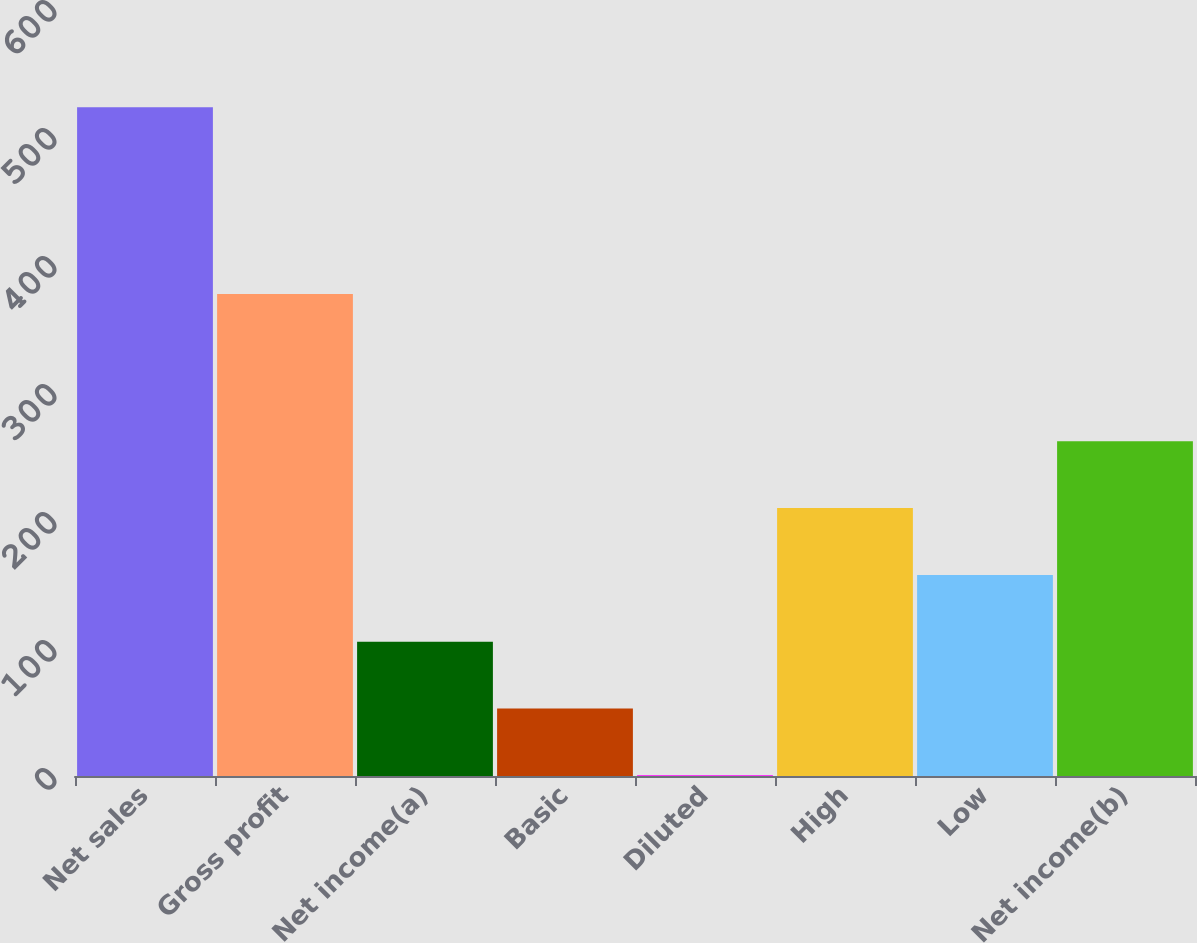Convert chart. <chart><loc_0><loc_0><loc_500><loc_500><bar_chart><fcel>Net sales<fcel>Gross profit<fcel>Net income(a)<fcel>Basic<fcel>Diluted<fcel>High<fcel>Low<fcel>Net income(b)<nl><fcel>522.4<fcel>376.5<fcel>104.92<fcel>52.74<fcel>0.56<fcel>209.28<fcel>157.1<fcel>261.46<nl></chart> 